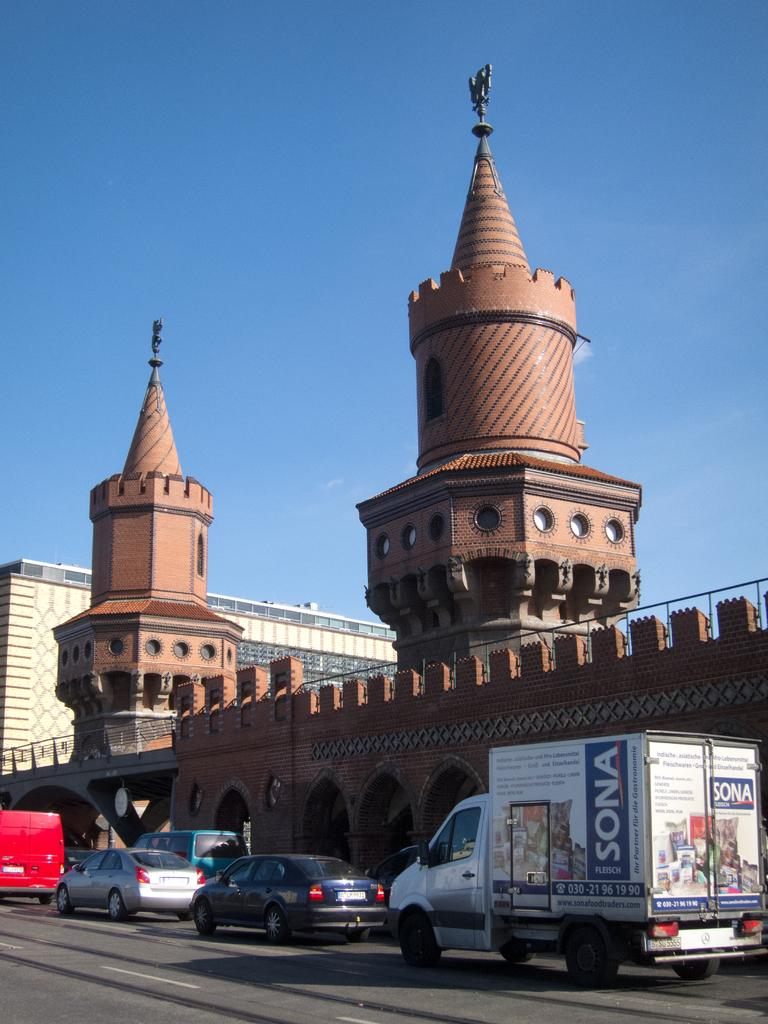What can be seen on the road in the image? There are vehicles on the road in the image. What is visible in the background of the image? There are buildings and the sky in the background of the image. What color is the sky in the image? The sky is blue in color in the image. Can you tell me how many people have given their approval for the line in the image? There is no line or indication of approval present in the image; it features vehicles on the road and buildings in the background. 